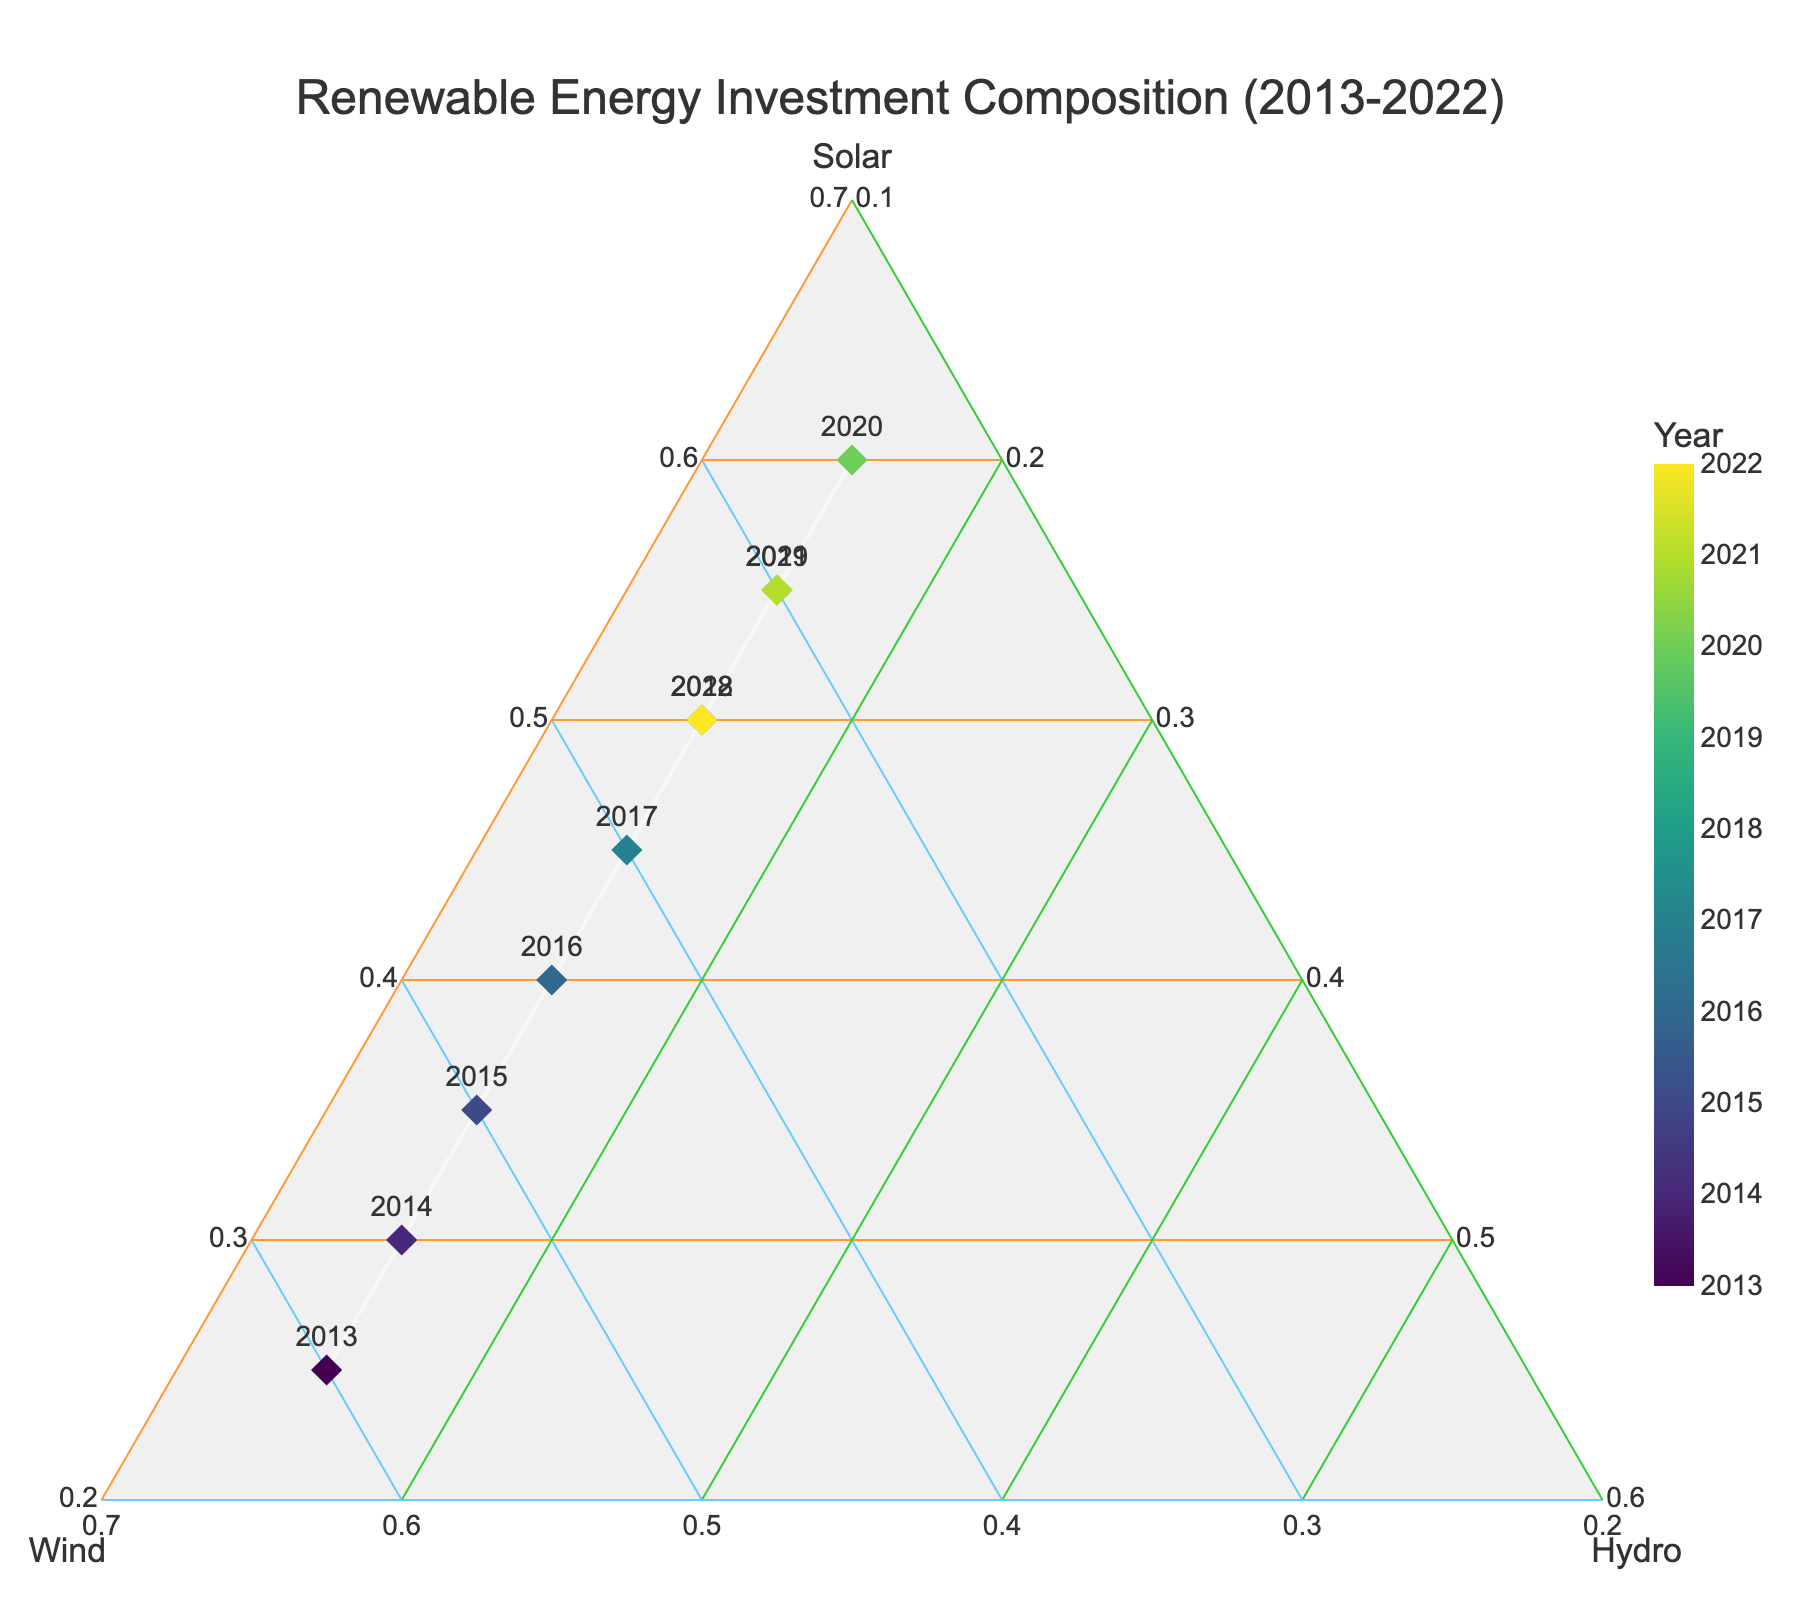what is the title of the plot? The title of the plot is a text presented prominently at the top of the figure. By observing the figure, we can identify the title.
Answer: Renewable Energy Investment Composition (2013-2022) How do Solar investments change between 2013 and 2022? To understand the trend in Solar investments, first look at the marker representing 2013 and note its position relative to the Solar axis. Then, observe the marker representing 2022 and note its position. The plot shows these changes based on their relative positions on the Solar axis.
Answer: They increase What is the general trend of Wind investments from 2013 to 2022? Inspect the markers starting from 2013 to 2022 along the Wind axis. Their positions will indicate how Wind investments have evolved over time.
Answer: They decrease Which year had the highest proportional investment in Solar energy? Identify the marker with the highest position relative to the Solar axis. The text label next to this marker denotes the corresponding year.
Answer: 2020 Can you identify any year where the composition of investments in Solar and Wind are equal? Check the positions of the markers relative to the Solar and Wind axes. The marker where these two values are equal will have the same proportion along both axes.
Answer: No, there isn't any year where these are equal In which year did Solar investments surpass Wind investments for the first time? Find the first marker where the proportion along Solar axis is higher than that along Wind axis. Observe the text label next to this marker.
Answer: 2015 How do investments in Hydropower remain throughout the decade? Look at the relative position of all markers along the Hydro axis. If they maintain a consistent proportion, it indicates stable investments in Hydropower.
Answer: Consistent at 15% What is the difference in Solar investments between 2017 and 2022? Note the positions of the markers for 2017 and 2022 along the Solar axis. Calculate the difference in their positions as a proportion.
Answer: Decrease by 5% What is the composition of renewable energy investments in the year 2016? Locate the marker for 2016 and note its relative positions along the Solar, Wind, and Hydro axes.
Answer: Solar: 40%, Wind: 45%, Hydro: 15% Compare investments in Solar and Wind in the year 2021. Which one is higher? Locate the marker for 2021 and compare its relative positions on the Solar and Wind axes.
Answer: Solar is higher 